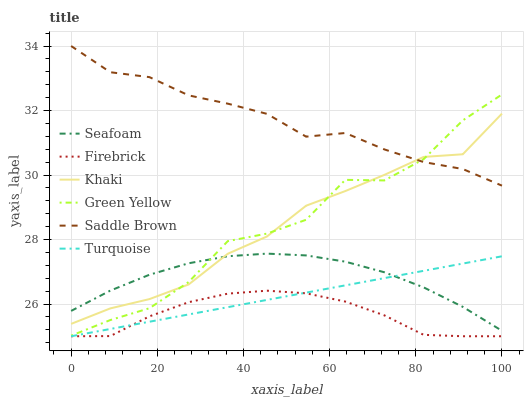Does Firebrick have the minimum area under the curve?
Answer yes or no. Yes. Does Saddle Brown have the maximum area under the curve?
Answer yes or no. Yes. Does Khaki have the minimum area under the curve?
Answer yes or no. No. Does Khaki have the maximum area under the curve?
Answer yes or no. No. Is Turquoise the smoothest?
Answer yes or no. Yes. Is Green Yellow the roughest?
Answer yes or no. Yes. Is Khaki the smoothest?
Answer yes or no. No. Is Khaki the roughest?
Answer yes or no. No. Does Khaki have the lowest value?
Answer yes or no. No. Does Saddle Brown have the highest value?
Answer yes or no. Yes. Does Khaki have the highest value?
Answer yes or no. No. Is Turquoise less than Green Yellow?
Answer yes or no. Yes. Is Saddle Brown greater than Turquoise?
Answer yes or no. Yes. Does Saddle Brown intersect Khaki?
Answer yes or no. Yes. Is Saddle Brown less than Khaki?
Answer yes or no. No. Is Saddle Brown greater than Khaki?
Answer yes or no. No. Does Turquoise intersect Green Yellow?
Answer yes or no. No. 